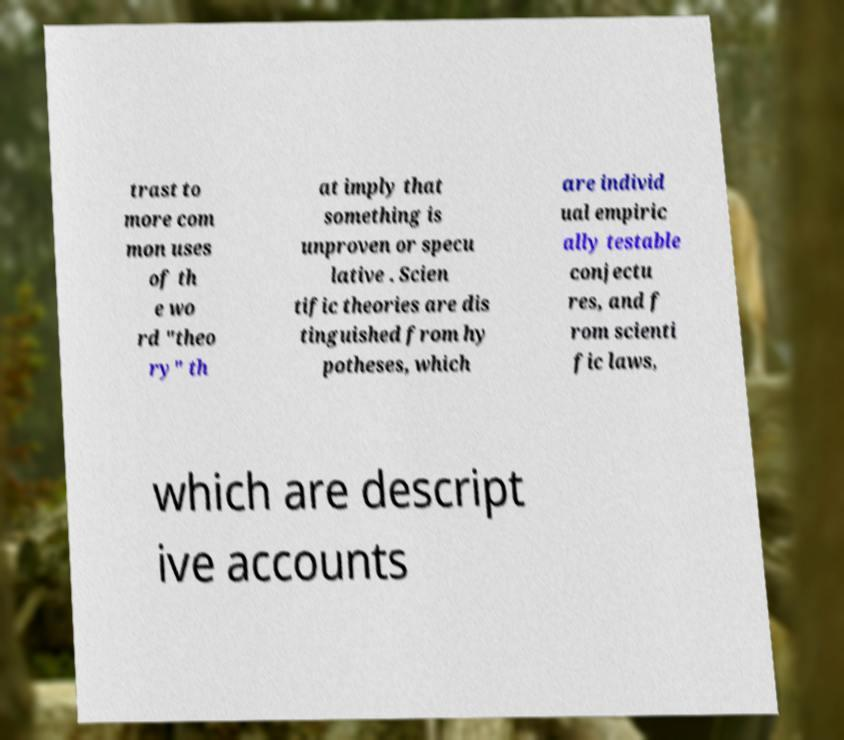Can you read and provide the text displayed in the image?This photo seems to have some interesting text. Can you extract and type it out for me? trast to more com mon uses of th e wo rd "theo ry" th at imply that something is unproven or specu lative . Scien tific theories are dis tinguished from hy potheses, which are individ ual empiric ally testable conjectu res, and f rom scienti fic laws, which are descript ive accounts 